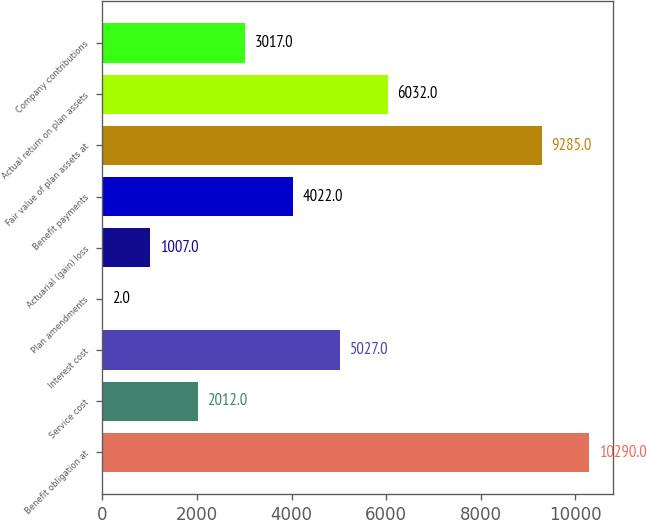<chart> <loc_0><loc_0><loc_500><loc_500><bar_chart><fcel>Benefit obligation at<fcel>Service cost<fcel>Interest cost<fcel>Plan amendments<fcel>Actuarial (gain) loss<fcel>Benefit payments<fcel>Fair value of plan assets at<fcel>Actual return on plan assets<fcel>Company contributions<nl><fcel>10290<fcel>2012<fcel>5027<fcel>2<fcel>1007<fcel>4022<fcel>9285<fcel>6032<fcel>3017<nl></chart> 